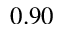Convert formula to latex. <formula><loc_0><loc_0><loc_500><loc_500>0 . 9 0</formula> 